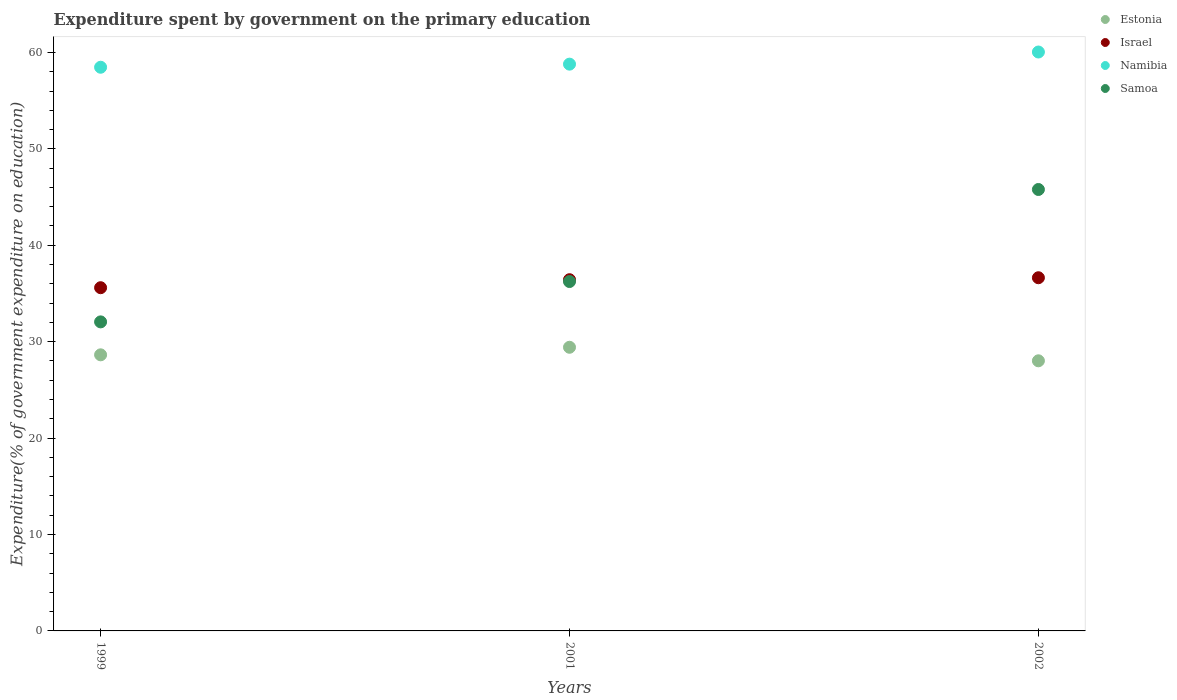Is the number of dotlines equal to the number of legend labels?
Provide a short and direct response. Yes. What is the expenditure spent by government on the primary education in Estonia in 1999?
Offer a terse response. 28.64. Across all years, what is the maximum expenditure spent by government on the primary education in Estonia?
Give a very brief answer. 29.42. Across all years, what is the minimum expenditure spent by government on the primary education in Israel?
Give a very brief answer. 35.6. In which year was the expenditure spent by government on the primary education in Estonia maximum?
Make the answer very short. 2001. What is the total expenditure spent by government on the primary education in Namibia in the graph?
Offer a very short reply. 177.3. What is the difference between the expenditure spent by government on the primary education in Israel in 1999 and that in 2002?
Give a very brief answer. -1.03. What is the difference between the expenditure spent by government on the primary education in Namibia in 2002 and the expenditure spent by government on the primary education in Estonia in 2001?
Your response must be concise. 30.62. What is the average expenditure spent by government on the primary education in Samoa per year?
Your answer should be very brief. 38.03. In the year 2001, what is the difference between the expenditure spent by government on the primary education in Namibia and expenditure spent by government on the primary education in Estonia?
Provide a succinct answer. 29.37. In how many years, is the expenditure spent by government on the primary education in Samoa greater than 20 %?
Offer a very short reply. 3. What is the ratio of the expenditure spent by government on the primary education in Namibia in 2001 to that in 2002?
Provide a succinct answer. 0.98. Is the expenditure spent by government on the primary education in Samoa in 1999 less than that in 2002?
Provide a succinct answer. Yes. Is the difference between the expenditure spent by government on the primary education in Namibia in 2001 and 2002 greater than the difference between the expenditure spent by government on the primary education in Estonia in 2001 and 2002?
Provide a succinct answer. No. What is the difference between the highest and the second highest expenditure spent by government on the primary education in Namibia?
Ensure brevity in your answer.  1.26. What is the difference between the highest and the lowest expenditure spent by government on the primary education in Namibia?
Offer a very short reply. 1.58. In how many years, is the expenditure spent by government on the primary education in Estonia greater than the average expenditure spent by government on the primary education in Estonia taken over all years?
Offer a very short reply. 1. Is the sum of the expenditure spent by government on the primary education in Israel in 1999 and 2002 greater than the maximum expenditure spent by government on the primary education in Estonia across all years?
Provide a short and direct response. Yes. Is it the case that in every year, the sum of the expenditure spent by government on the primary education in Samoa and expenditure spent by government on the primary education in Estonia  is greater than the sum of expenditure spent by government on the primary education in Namibia and expenditure spent by government on the primary education in Israel?
Provide a short and direct response. Yes. Is it the case that in every year, the sum of the expenditure spent by government on the primary education in Estonia and expenditure spent by government on the primary education in Namibia  is greater than the expenditure spent by government on the primary education in Israel?
Keep it short and to the point. Yes. Does the expenditure spent by government on the primary education in Namibia monotonically increase over the years?
Make the answer very short. Yes. Is the expenditure spent by government on the primary education in Samoa strictly greater than the expenditure spent by government on the primary education in Namibia over the years?
Keep it short and to the point. No. Is the expenditure spent by government on the primary education in Israel strictly less than the expenditure spent by government on the primary education in Estonia over the years?
Your response must be concise. No. How many dotlines are there?
Your response must be concise. 4. How many years are there in the graph?
Give a very brief answer. 3. What is the difference between two consecutive major ticks on the Y-axis?
Give a very brief answer. 10. Are the values on the major ticks of Y-axis written in scientific E-notation?
Provide a succinct answer. No. Does the graph contain any zero values?
Offer a terse response. No. Does the graph contain grids?
Your response must be concise. No. How are the legend labels stacked?
Provide a succinct answer. Vertical. What is the title of the graph?
Provide a short and direct response. Expenditure spent by government on the primary education. Does "Guinea" appear as one of the legend labels in the graph?
Your answer should be very brief. No. What is the label or title of the Y-axis?
Offer a terse response. Expenditure(% of government expenditure on education). What is the Expenditure(% of government expenditure on education) in Estonia in 1999?
Your answer should be compact. 28.64. What is the Expenditure(% of government expenditure on education) of Israel in 1999?
Ensure brevity in your answer.  35.6. What is the Expenditure(% of government expenditure on education) in Namibia in 1999?
Provide a short and direct response. 58.47. What is the Expenditure(% of government expenditure on education) in Samoa in 1999?
Ensure brevity in your answer.  32.05. What is the Expenditure(% of government expenditure on education) in Estonia in 2001?
Your response must be concise. 29.42. What is the Expenditure(% of government expenditure on education) in Israel in 2001?
Ensure brevity in your answer.  36.43. What is the Expenditure(% of government expenditure on education) in Namibia in 2001?
Give a very brief answer. 58.79. What is the Expenditure(% of government expenditure on education) in Samoa in 2001?
Ensure brevity in your answer.  36.24. What is the Expenditure(% of government expenditure on education) in Estonia in 2002?
Your response must be concise. 28.02. What is the Expenditure(% of government expenditure on education) in Israel in 2002?
Make the answer very short. 36.63. What is the Expenditure(% of government expenditure on education) in Namibia in 2002?
Ensure brevity in your answer.  60.05. What is the Expenditure(% of government expenditure on education) in Samoa in 2002?
Your response must be concise. 45.79. Across all years, what is the maximum Expenditure(% of government expenditure on education) in Estonia?
Give a very brief answer. 29.42. Across all years, what is the maximum Expenditure(% of government expenditure on education) of Israel?
Give a very brief answer. 36.63. Across all years, what is the maximum Expenditure(% of government expenditure on education) in Namibia?
Offer a terse response. 60.05. Across all years, what is the maximum Expenditure(% of government expenditure on education) of Samoa?
Your answer should be compact. 45.79. Across all years, what is the minimum Expenditure(% of government expenditure on education) of Estonia?
Your response must be concise. 28.02. Across all years, what is the minimum Expenditure(% of government expenditure on education) in Israel?
Provide a succinct answer. 35.6. Across all years, what is the minimum Expenditure(% of government expenditure on education) in Namibia?
Your answer should be compact. 58.47. Across all years, what is the minimum Expenditure(% of government expenditure on education) of Samoa?
Your answer should be compact. 32.05. What is the total Expenditure(% of government expenditure on education) of Estonia in the graph?
Provide a succinct answer. 86.08. What is the total Expenditure(% of government expenditure on education) in Israel in the graph?
Keep it short and to the point. 108.66. What is the total Expenditure(% of government expenditure on education) of Namibia in the graph?
Provide a short and direct response. 177.3. What is the total Expenditure(% of government expenditure on education) in Samoa in the graph?
Your answer should be very brief. 114.08. What is the difference between the Expenditure(% of government expenditure on education) of Estonia in 1999 and that in 2001?
Your answer should be compact. -0.78. What is the difference between the Expenditure(% of government expenditure on education) in Israel in 1999 and that in 2001?
Make the answer very short. -0.83. What is the difference between the Expenditure(% of government expenditure on education) of Namibia in 1999 and that in 2001?
Make the answer very short. -0.32. What is the difference between the Expenditure(% of government expenditure on education) in Samoa in 1999 and that in 2001?
Your answer should be very brief. -4.18. What is the difference between the Expenditure(% of government expenditure on education) in Estonia in 1999 and that in 2002?
Your answer should be compact. 0.62. What is the difference between the Expenditure(% of government expenditure on education) in Israel in 1999 and that in 2002?
Give a very brief answer. -1.03. What is the difference between the Expenditure(% of government expenditure on education) of Namibia in 1999 and that in 2002?
Make the answer very short. -1.58. What is the difference between the Expenditure(% of government expenditure on education) of Samoa in 1999 and that in 2002?
Provide a short and direct response. -13.73. What is the difference between the Expenditure(% of government expenditure on education) of Estonia in 2001 and that in 2002?
Offer a very short reply. 1.4. What is the difference between the Expenditure(% of government expenditure on education) in Israel in 2001 and that in 2002?
Give a very brief answer. -0.2. What is the difference between the Expenditure(% of government expenditure on education) of Namibia in 2001 and that in 2002?
Your answer should be compact. -1.26. What is the difference between the Expenditure(% of government expenditure on education) in Samoa in 2001 and that in 2002?
Your response must be concise. -9.55. What is the difference between the Expenditure(% of government expenditure on education) in Estonia in 1999 and the Expenditure(% of government expenditure on education) in Israel in 2001?
Keep it short and to the point. -7.79. What is the difference between the Expenditure(% of government expenditure on education) in Estonia in 1999 and the Expenditure(% of government expenditure on education) in Namibia in 2001?
Offer a very short reply. -30.15. What is the difference between the Expenditure(% of government expenditure on education) of Estonia in 1999 and the Expenditure(% of government expenditure on education) of Samoa in 2001?
Your answer should be compact. -7.6. What is the difference between the Expenditure(% of government expenditure on education) of Israel in 1999 and the Expenditure(% of government expenditure on education) of Namibia in 2001?
Provide a succinct answer. -23.19. What is the difference between the Expenditure(% of government expenditure on education) of Israel in 1999 and the Expenditure(% of government expenditure on education) of Samoa in 2001?
Give a very brief answer. -0.64. What is the difference between the Expenditure(% of government expenditure on education) in Namibia in 1999 and the Expenditure(% of government expenditure on education) in Samoa in 2001?
Your answer should be compact. 22.23. What is the difference between the Expenditure(% of government expenditure on education) of Estonia in 1999 and the Expenditure(% of government expenditure on education) of Israel in 2002?
Provide a short and direct response. -8. What is the difference between the Expenditure(% of government expenditure on education) of Estonia in 1999 and the Expenditure(% of government expenditure on education) of Namibia in 2002?
Give a very brief answer. -31.41. What is the difference between the Expenditure(% of government expenditure on education) of Estonia in 1999 and the Expenditure(% of government expenditure on education) of Samoa in 2002?
Give a very brief answer. -17.15. What is the difference between the Expenditure(% of government expenditure on education) in Israel in 1999 and the Expenditure(% of government expenditure on education) in Namibia in 2002?
Ensure brevity in your answer.  -24.45. What is the difference between the Expenditure(% of government expenditure on education) of Israel in 1999 and the Expenditure(% of government expenditure on education) of Samoa in 2002?
Ensure brevity in your answer.  -10.19. What is the difference between the Expenditure(% of government expenditure on education) in Namibia in 1999 and the Expenditure(% of government expenditure on education) in Samoa in 2002?
Keep it short and to the point. 12.68. What is the difference between the Expenditure(% of government expenditure on education) in Estonia in 2001 and the Expenditure(% of government expenditure on education) in Israel in 2002?
Offer a terse response. -7.21. What is the difference between the Expenditure(% of government expenditure on education) of Estonia in 2001 and the Expenditure(% of government expenditure on education) of Namibia in 2002?
Your response must be concise. -30.62. What is the difference between the Expenditure(% of government expenditure on education) of Estonia in 2001 and the Expenditure(% of government expenditure on education) of Samoa in 2002?
Keep it short and to the point. -16.37. What is the difference between the Expenditure(% of government expenditure on education) in Israel in 2001 and the Expenditure(% of government expenditure on education) in Namibia in 2002?
Give a very brief answer. -23.62. What is the difference between the Expenditure(% of government expenditure on education) in Israel in 2001 and the Expenditure(% of government expenditure on education) in Samoa in 2002?
Keep it short and to the point. -9.36. What is the difference between the Expenditure(% of government expenditure on education) of Namibia in 2001 and the Expenditure(% of government expenditure on education) of Samoa in 2002?
Provide a short and direct response. 13. What is the average Expenditure(% of government expenditure on education) in Estonia per year?
Keep it short and to the point. 28.69. What is the average Expenditure(% of government expenditure on education) of Israel per year?
Your response must be concise. 36.22. What is the average Expenditure(% of government expenditure on education) of Namibia per year?
Provide a succinct answer. 59.1. What is the average Expenditure(% of government expenditure on education) of Samoa per year?
Give a very brief answer. 38.03. In the year 1999, what is the difference between the Expenditure(% of government expenditure on education) in Estonia and Expenditure(% of government expenditure on education) in Israel?
Make the answer very short. -6.96. In the year 1999, what is the difference between the Expenditure(% of government expenditure on education) in Estonia and Expenditure(% of government expenditure on education) in Namibia?
Provide a short and direct response. -29.83. In the year 1999, what is the difference between the Expenditure(% of government expenditure on education) in Estonia and Expenditure(% of government expenditure on education) in Samoa?
Your answer should be compact. -3.42. In the year 1999, what is the difference between the Expenditure(% of government expenditure on education) of Israel and Expenditure(% of government expenditure on education) of Namibia?
Offer a very short reply. -22.87. In the year 1999, what is the difference between the Expenditure(% of government expenditure on education) in Israel and Expenditure(% of government expenditure on education) in Samoa?
Provide a short and direct response. 3.54. In the year 1999, what is the difference between the Expenditure(% of government expenditure on education) of Namibia and Expenditure(% of government expenditure on education) of Samoa?
Give a very brief answer. 26.41. In the year 2001, what is the difference between the Expenditure(% of government expenditure on education) of Estonia and Expenditure(% of government expenditure on education) of Israel?
Give a very brief answer. -7.01. In the year 2001, what is the difference between the Expenditure(% of government expenditure on education) in Estonia and Expenditure(% of government expenditure on education) in Namibia?
Your answer should be compact. -29.37. In the year 2001, what is the difference between the Expenditure(% of government expenditure on education) in Estonia and Expenditure(% of government expenditure on education) in Samoa?
Keep it short and to the point. -6.82. In the year 2001, what is the difference between the Expenditure(% of government expenditure on education) of Israel and Expenditure(% of government expenditure on education) of Namibia?
Your answer should be compact. -22.36. In the year 2001, what is the difference between the Expenditure(% of government expenditure on education) in Israel and Expenditure(% of government expenditure on education) in Samoa?
Give a very brief answer. 0.19. In the year 2001, what is the difference between the Expenditure(% of government expenditure on education) in Namibia and Expenditure(% of government expenditure on education) in Samoa?
Give a very brief answer. 22.55. In the year 2002, what is the difference between the Expenditure(% of government expenditure on education) in Estonia and Expenditure(% of government expenditure on education) in Israel?
Offer a terse response. -8.62. In the year 2002, what is the difference between the Expenditure(% of government expenditure on education) of Estonia and Expenditure(% of government expenditure on education) of Namibia?
Provide a short and direct response. -32.03. In the year 2002, what is the difference between the Expenditure(% of government expenditure on education) in Estonia and Expenditure(% of government expenditure on education) in Samoa?
Offer a terse response. -17.77. In the year 2002, what is the difference between the Expenditure(% of government expenditure on education) of Israel and Expenditure(% of government expenditure on education) of Namibia?
Your answer should be compact. -23.41. In the year 2002, what is the difference between the Expenditure(% of government expenditure on education) of Israel and Expenditure(% of government expenditure on education) of Samoa?
Provide a short and direct response. -9.15. In the year 2002, what is the difference between the Expenditure(% of government expenditure on education) of Namibia and Expenditure(% of government expenditure on education) of Samoa?
Provide a succinct answer. 14.26. What is the ratio of the Expenditure(% of government expenditure on education) of Estonia in 1999 to that in 2001?
Your answer should be very brief. 0.97. What is the ratio of the Expenditure(% of government expenditure on education) of Israel in 1999 to that in 2001?
Ensure brevity in your answer.  0.98. What is the ratio of the Expenditure(% of government expenditure on education) of Samoa in 1999 to that in 2001?
Make the answer very short. 0.88. What is the ratio of the Expenditure(% of government expenditure on education) of Estonia in 1999 to that in 2002?
Give a very brief answer. 1.02. What is the ratio of the Expenditure(% of government expenditure on education) of Israel in 1999 to that in 2002?
Your answer should be compact. 0.97. What is the ratio of the Expenditure(% of government expenditure on education) of Namibia in 1999 to that in 2002?
Keep it short and to the point. 0.97. What is the ratio of the Expenditure(% of government expenditure on education) in Samoa in 1999 to that in 2002?
Offer a terse response. 0.7. What is the ratio of the Expenditure(% of government expenditure on education) of Estonia in 2001 to that in 2002?
Give a very brief answer. 1.05. What is the ratio of the Expenditure(% of government expenditure on education) of Israel in 2001 to that in 2002?
Your answer should be very brief. 0.99. What is the ratio of the Expenditure(% of government expenditure on education) of Samoa in 2001 to that in 2002?
Your response must be concise. 0.79. What is the difference between the highest and the second highest Expenditure(% of government expenditure on education) of Estonia?
Make the answer very short. 0.78. What is the difference between the highest and the second highest Expenditure(% of government expenditure on education) in Israel?
Offer a very short reply. 0.2. What is the difference between the highest and the second highest Expenditure(% of government expenditure on education) of Namibia?
Provide a short and direct response. 1.26. What is the difference between the highest and the second highest Expenditure(% of government expenditure on education) in Samoa?
Keep it short and to the point. 9.55. What is the difference between the highest and the lowest Expenditure(% of government expenditure on education) of Estonia?
Ensure brevity in your answer.  1.4. What is the difference between the highest and the lowest Expenditure(% of government expenditure on education) in Israel?
Make the answer very short. 1.03. What is the difference between the highest and the lowest Expenditure(% of government expenditure on education) in Namibia?
Give a very brief answer. 1.58. What is the difference between the highest and the lowest Expenditure(% of government expenditure on education) in Samoa?
Offer a terse response. 13.73. 